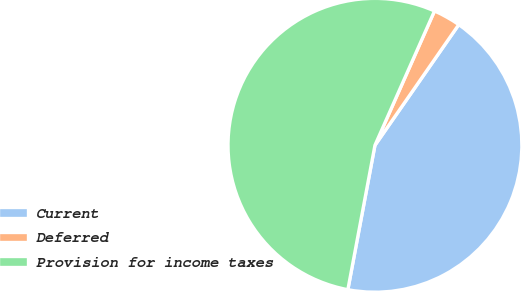<chart> <loc_0><loc_0><loc_500><loc_500><pie_chart><fcel>Current<fcel>Deferred<fcel>Provision for income taxes<nl><fcel>43.29%<fcel>3.02%<fcel>53.69%<nl></chart> 